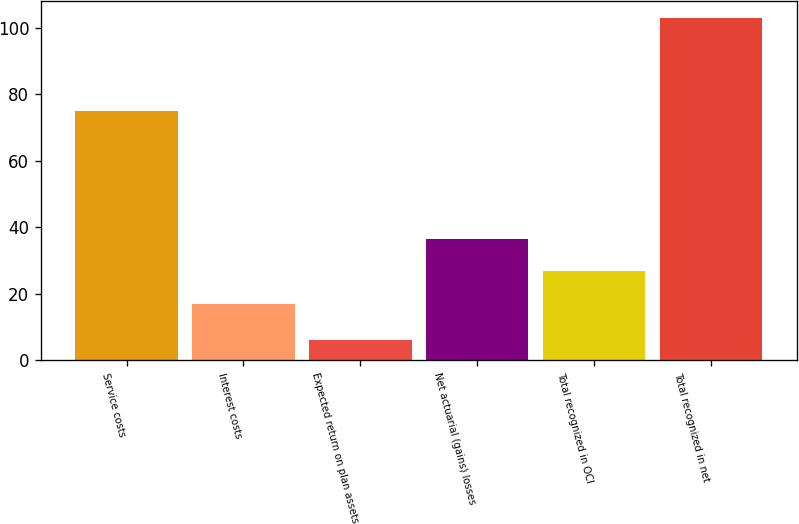<chart> <loc_0><loc_0><loc_500><loc_500><bar_chart><fcel>Service costs<fcel>Interest costs<fcel>Expected return on plan assets<fcel>Net actuarial (gains) losses<fcel>Total recognized in OCI<fcel>Total recognized in net<nl><fcel>75<fcel>17<fcel>6<fcel>36.4<fcel>26.7<fcel>103<nl></chart> 